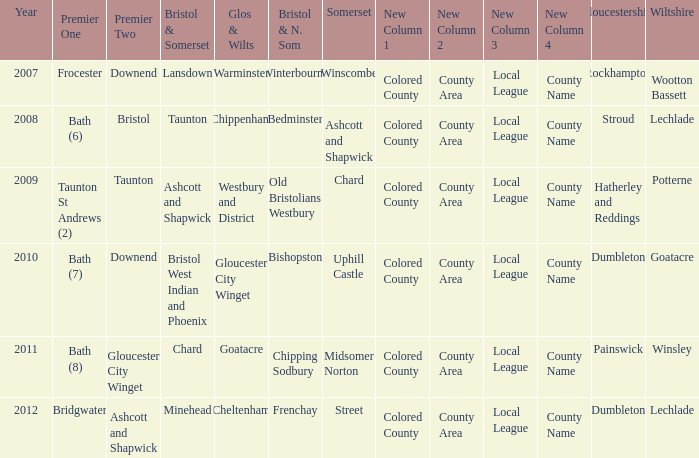Who many times is gloucestershire is painswick? 1.0. 